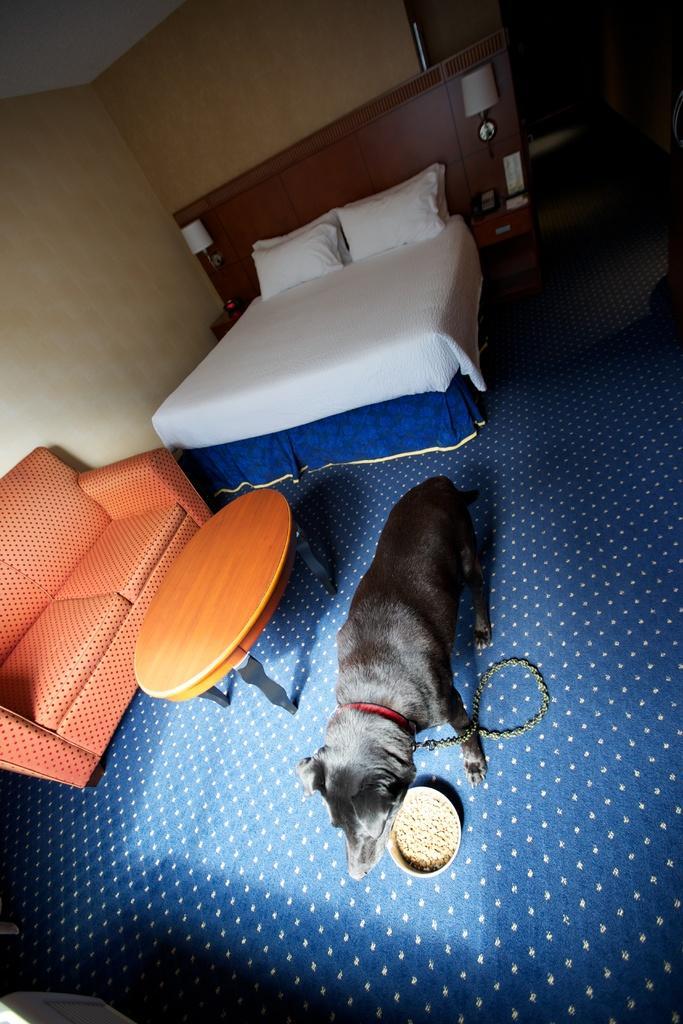How would you summarize this image in a sentence or two? In this image there is a dog eating the food in the plate ,table , couch , bed , blanket , 2 pillows , lamp , wall. 